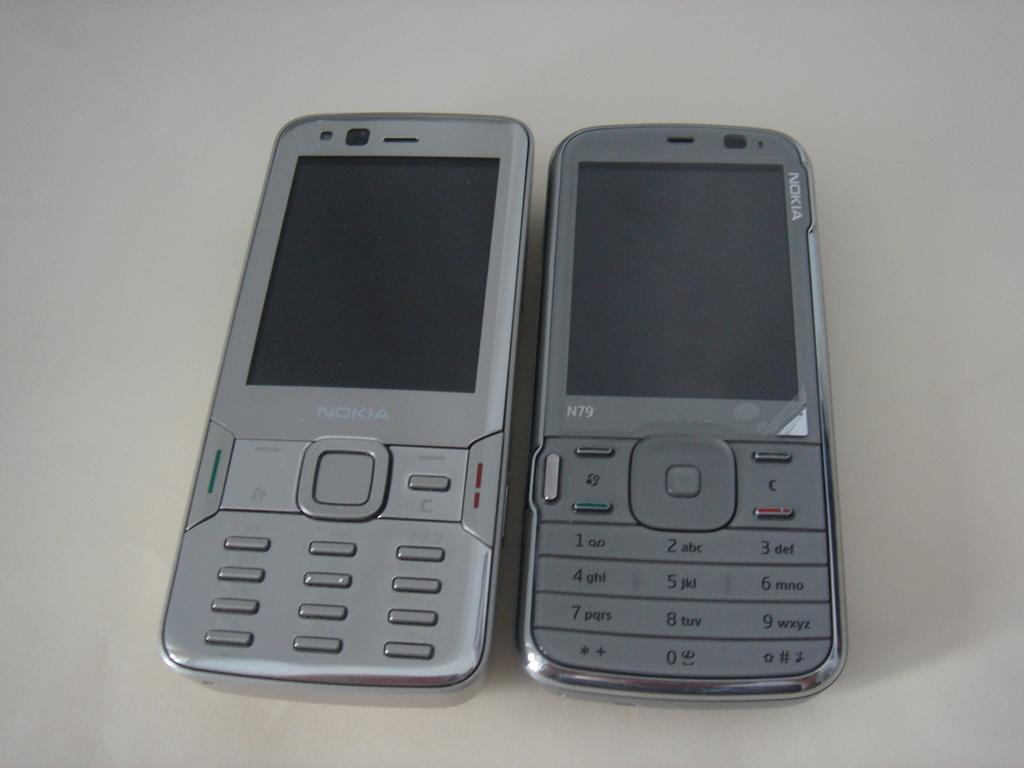<image>
Describe the image concisely. two silver Nokia cell phones on a white table 